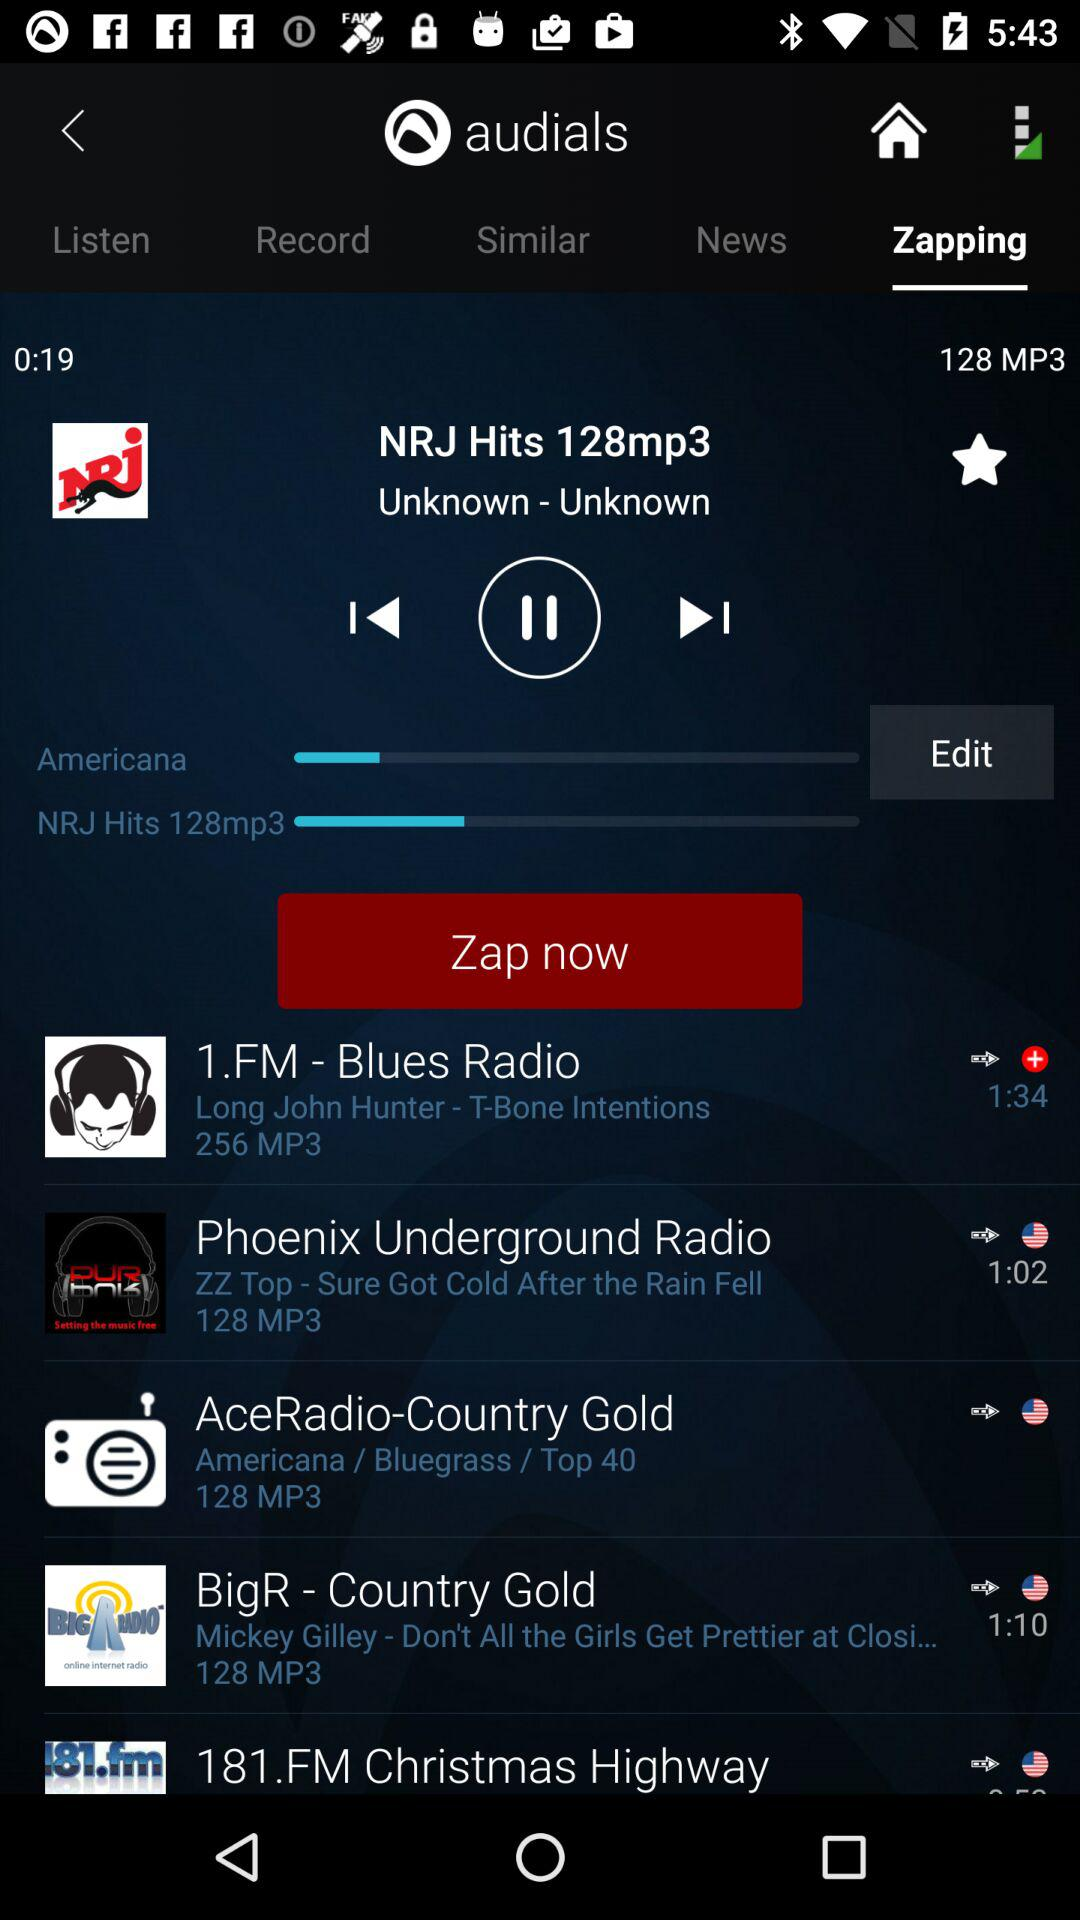When was the last recording made?
When the provided information is insufficient, respond with <no answer>. <no answer> 